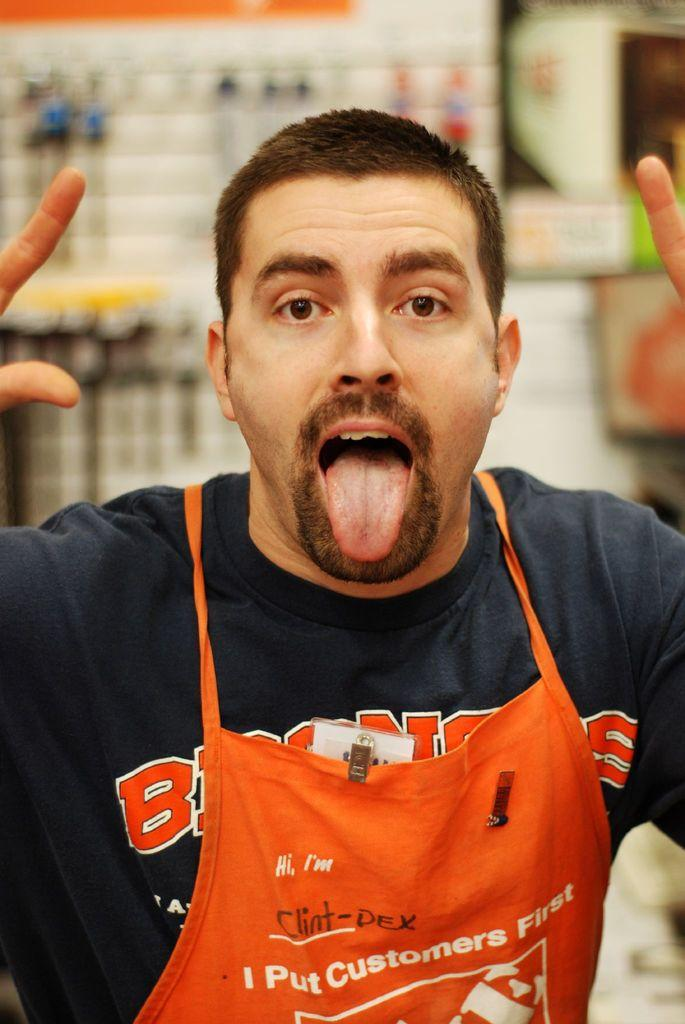<image>
Give a short and clear explanation of the subsequent image. a man that is wearing an orange apron and has a Broncos shirt on 